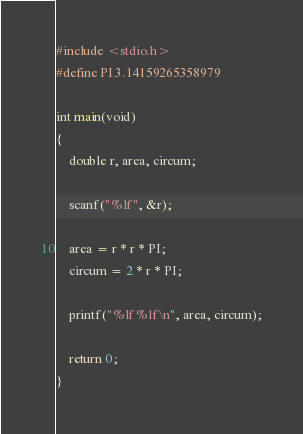Convert code to text. <code><loc_0><loc_0><loc_500><loc_500><_C_>#include <stdio.h>
#define PI 3.14159265358979

int main(void)
{
    double r, area, circum;

    scanf("%lf", &r);

    area = r * r * PI;
    circum = 2 * r * PI;

    printf("%lf %lf\n", area, circum);

    return 0;
}
</code> 